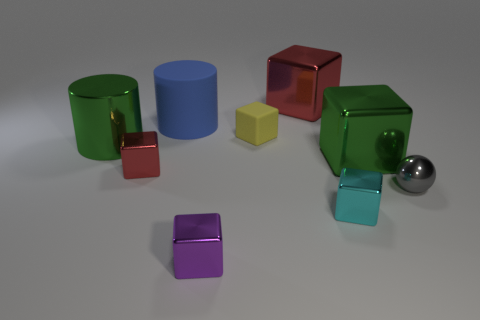Subtract 2 cubes. How many cubes are left? 4 Subtract all matte cubes. How many cubes are left? 5 Subtract all cyan cubes. How many cubes are left? 5 Subtract all brown cubes. Subtract all purple cylinders. How many cubes are left? 6 Add 1 large green cylinders. How many objects exist? 10 Subtract all cylinders. How many objects are left? 7 Add 3 cyan blocks. How many cyan blocks are left? 4 Add 4 big green metal cylinders. How many big green metal cylinders exist? 5 Subtract 1 green blocks. How many objects are left? 8 Subtract all tiny blue balls. Subtract all big green cylinders. How many objects are left? 8 